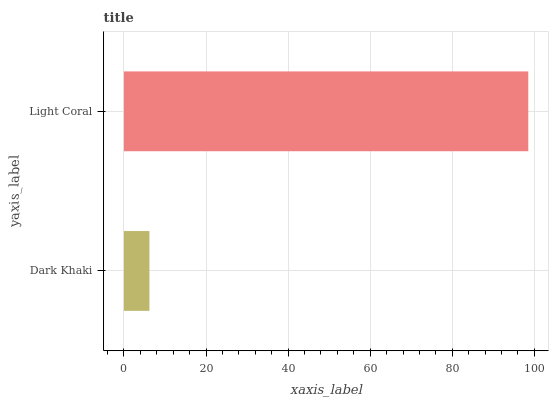Is Dark Khaki the minimum?
Answer yes or no. Yes. Is Light Coral the maximum?
Answer yes or no. Yes. Is Light Coral the minimum?
Answer yes or no. No. Is Light Coral greater than Dark Khaki?
Answer yes or no. Yes. Is Dark Khaki less than Light Coral?
Answer yes or no. Yes. Is Dark Khaki greater than Light Coral?
Answer yes or no. No. Is Light Coral less than Dark Khaki?
Answer yes or no. No. Is Light Coral the high median?
Answer yes or no. Yes. Is Dark Khaki the low median?
Answer yes or no. Yes. Is Dark Khaki the high median?
Answer yes or no. No. Is Light Coral the low median?
Answer yes or no. No. 